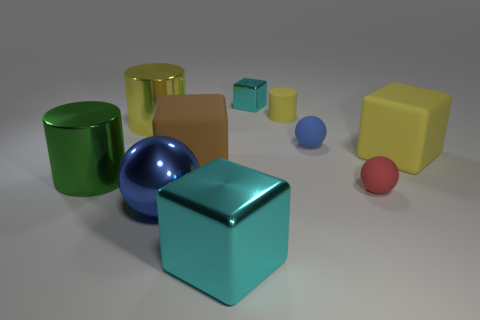Are the cylinder that is to the right of the large cyan metal thing and the large yellow object that is on the right side of the small yellow matte cylinder made of the same material? Based on the image, both the cylinder to the right of the larger cyan metal object and the large yellow object next to the small yellow matte cylinder appear to have reflective surfaces that suggest they could be made of a similar glossy or shiny material, possibly a type of polished metal or plastic with a reflective coating. However, without more information, we can't determine with certainty if they are made from the exact same material. 